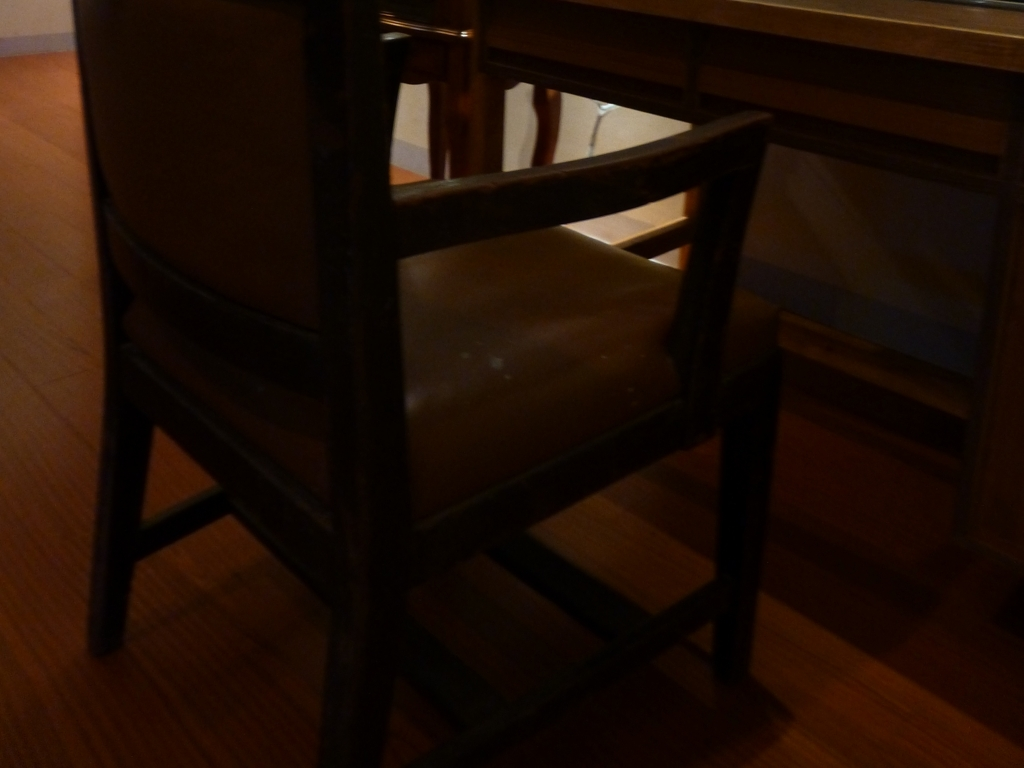What could be done to improve the quality of this image? To improve the quality, the image could be brightened either through post-processing methods using image editing software, or by taking another photo with better lighting conditions, ensuring the subject is well-lit and details are more visible. 